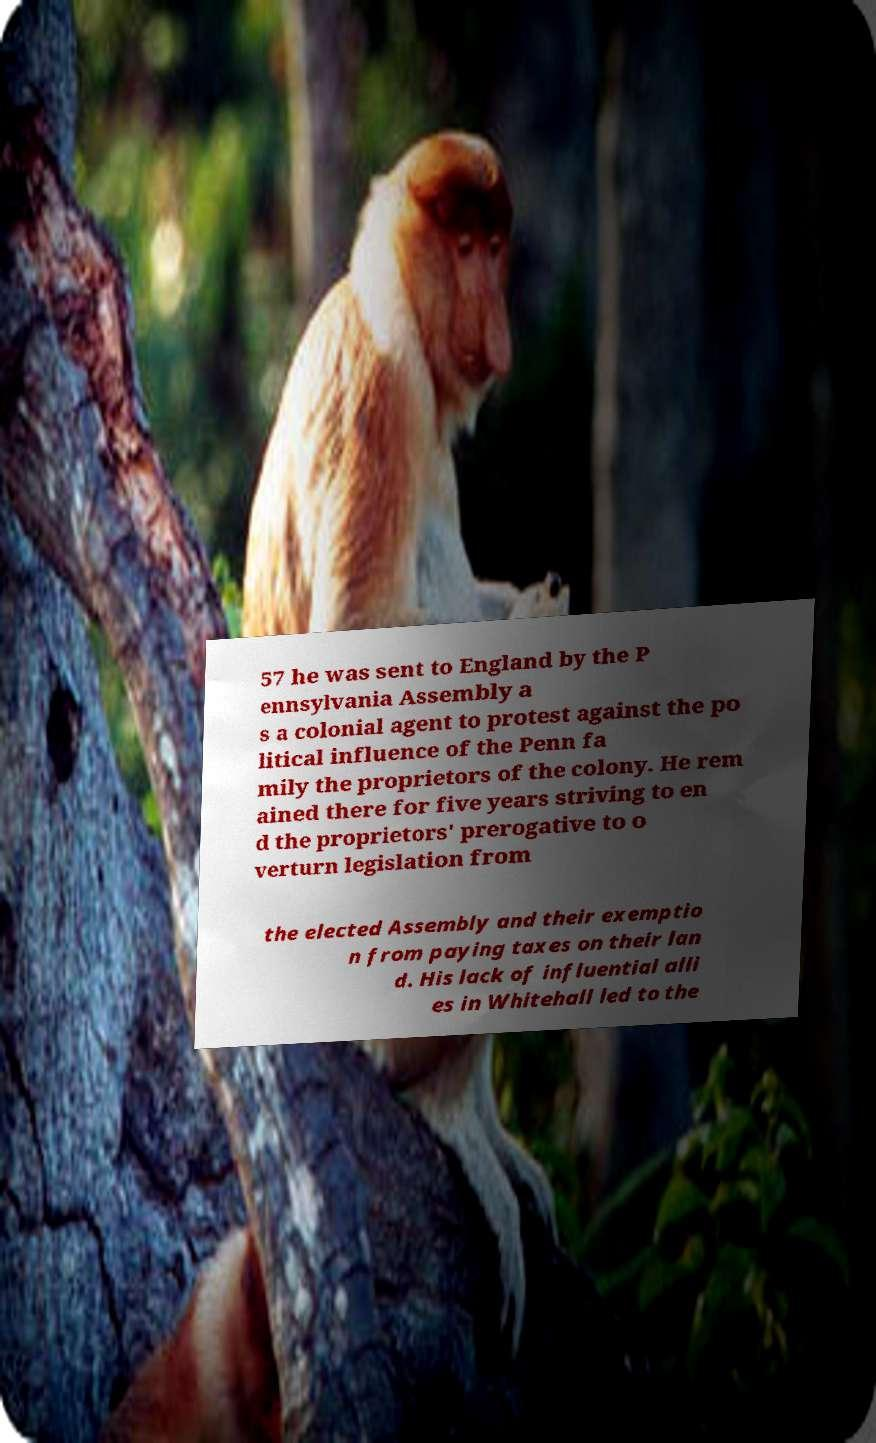Please identify and transcribe the text found in this image. 57 he was sent to England by the P ennsylvania Assembly a s a colonial agent to protest against the po litical influence of the Penn fa mily the proprietors of the colony. He rem ained there for five years striving to en d the proprietors' prerogative to o verturn legislation from the elected Assembly and their exemptio n from paying taxes on their lan d. His lack of influential alli es in Whitehall led to the 